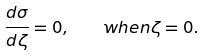<formula> <loc_0><loc_0><loc_500><loc_500>\frac { d \sigma } { d \zeta } = 0 , \quad w h e n \zeta = 0 .</formula> 